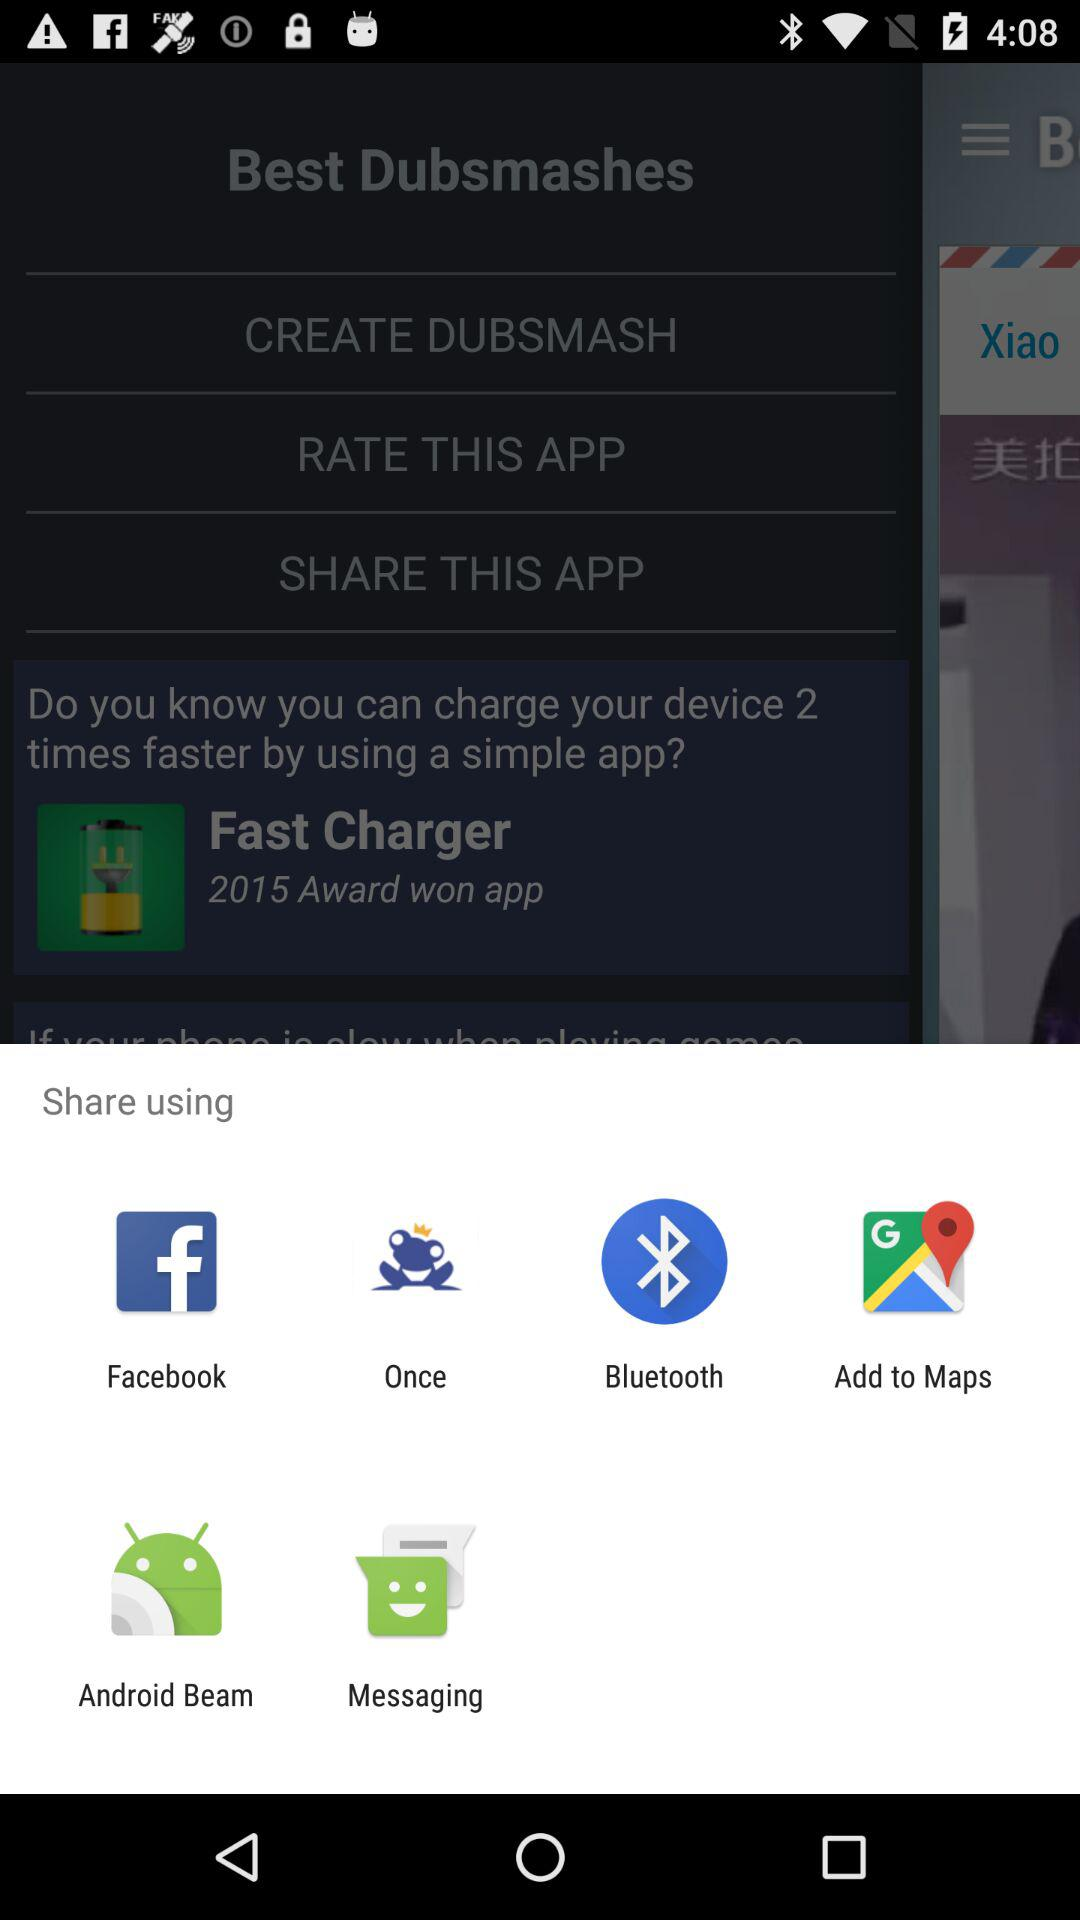Which app can we use to share? You can use "Facebook", "Once", "Bluetooth", "Maps", "Android Beam" and "Messaging" to share. 